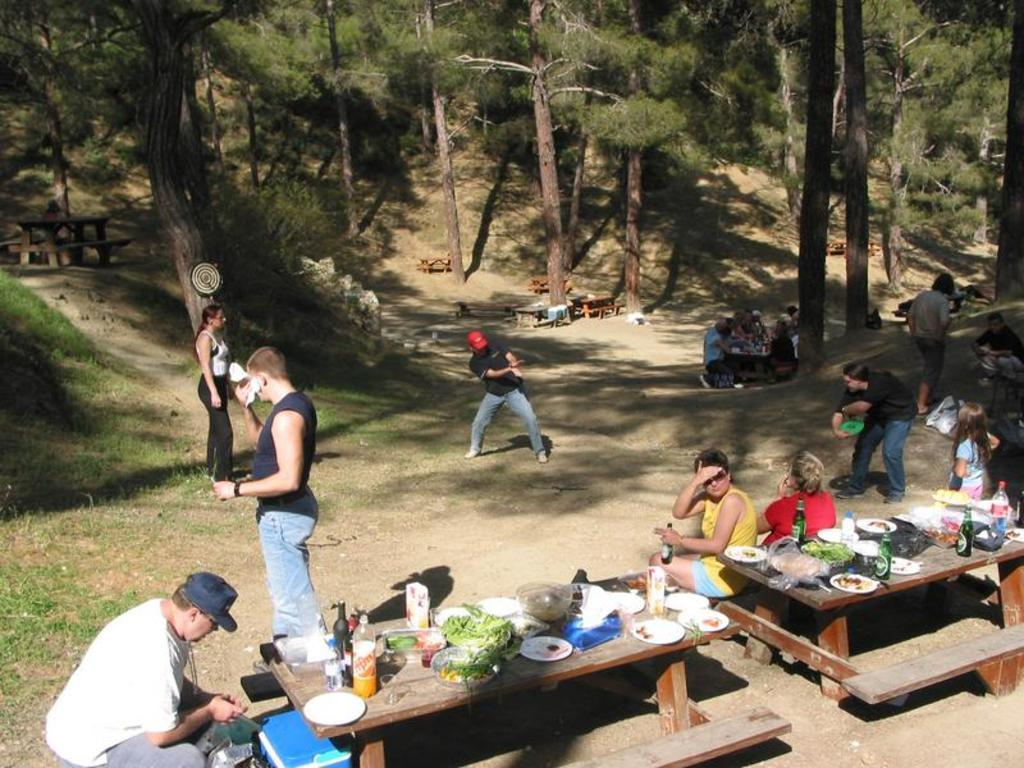What are the people in the image doing? There are people sitting and standing in the image. What can be seen in the background of the image? There are trees and benches in the background of the image. What type of joke can be seen being told by the trees in the image? There are no jokes or trees telling jokes in the image; it features people sitting and standing with trees and benches in the background. 